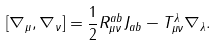<formula> <loc_0><loc_0><loc_500><loc_500>[ \nabla _ { \mu } , \nabla _ { \nu } ] = \frac { 1 } { 2 } R _ { \mu \nu } ^ { a b } J _ { a b } - T _ { \mu \nu } ^ { \lambda } \nabla _ { \lambda } .</formula> 